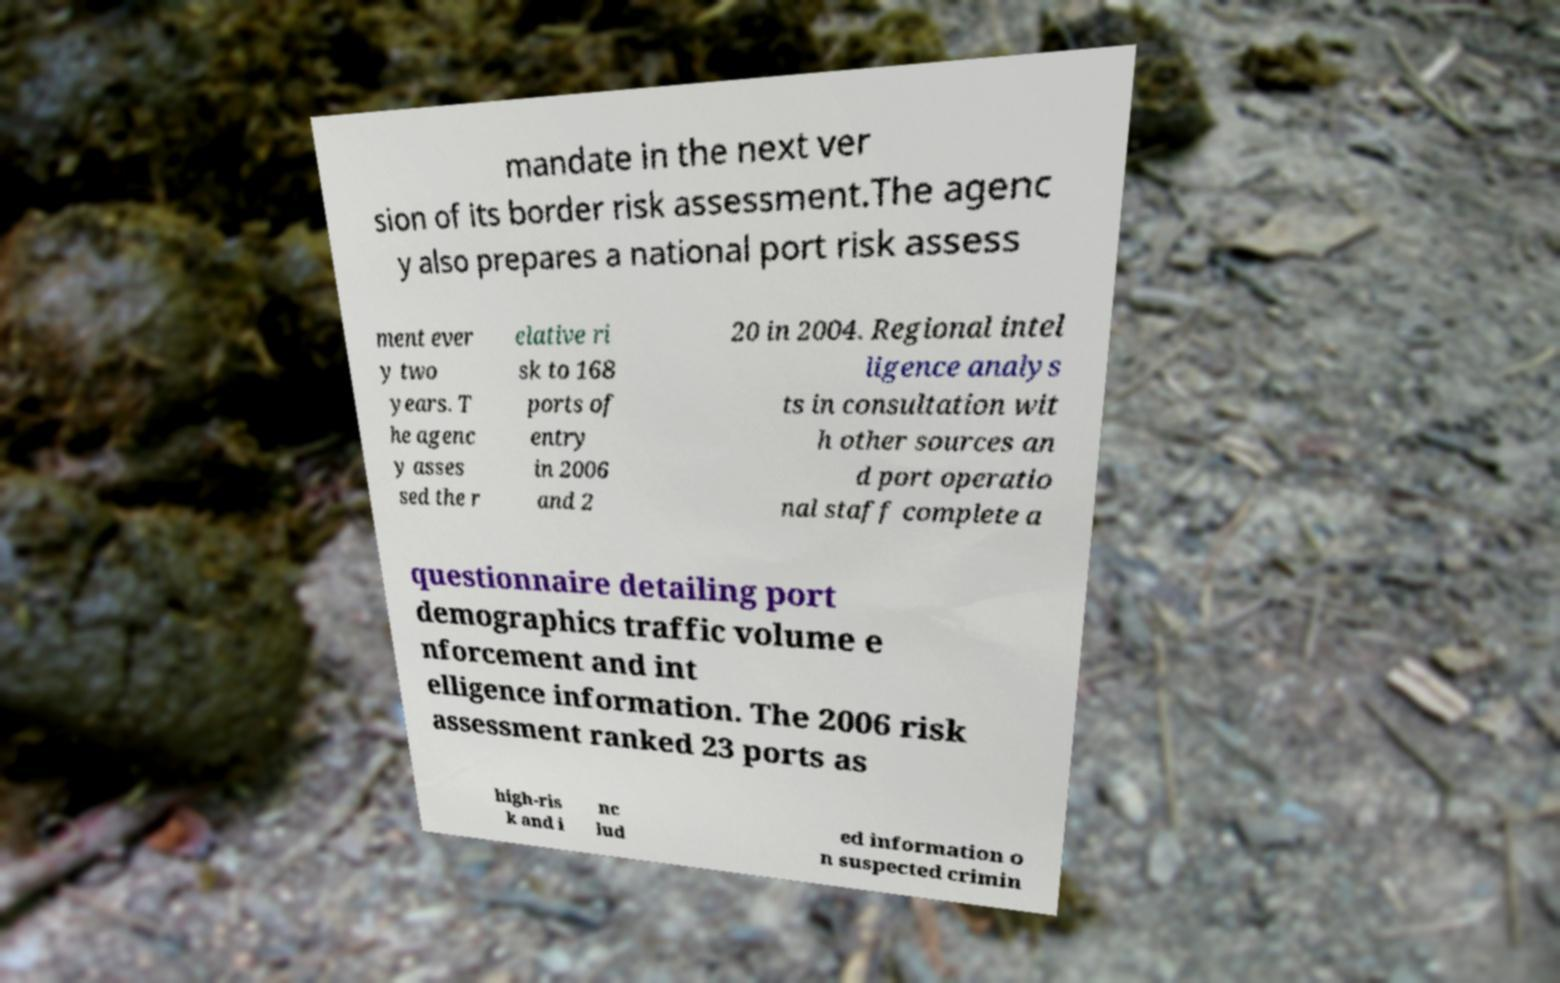Could you extract and type out the text from this image? mandate in the next ver sion of its border risk assessment.The agenc y also prepares a national port risk assess ment ever y two years. T he agenc y asses sed the r elative ri sk to 168 ports of entry in 2006 and 2 20 in 2004. Regional intel ligence analys ts in consultation wit h other sources an d port operatio nal staff complete a questionnaire detailing port demographics traffic volume e nforcement and int elligence information. The 2006 risk assessment ranked 23 ports as high-ris k and i nc lud ed information o n suspected crimin 